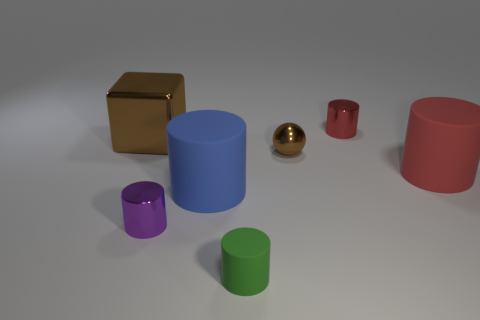How many red cylinders must be subtracted to get 1 red cylinders? 1 Subtract 2 cylinders. How many cylinders are left? 3 Subtract all blue cylinders. How many cylinders are left? 4 Subtract all blue matte cylinders. How many cylinders are left? 4 Subtract all gray cylinders. Subtract all gray balls. How many cylinders are left? 5 Add 2 large cyan spheres. How many objects exist? 9 Subtract all cylinders. How many objects are left? 2 Subtract 0 brown cylinders. How many objects are left? 7 Subtract all tiny red cubes. Subtract all purple cylinders. How many objects are left? 6 Add 7 big things. How many big things are left? 10 